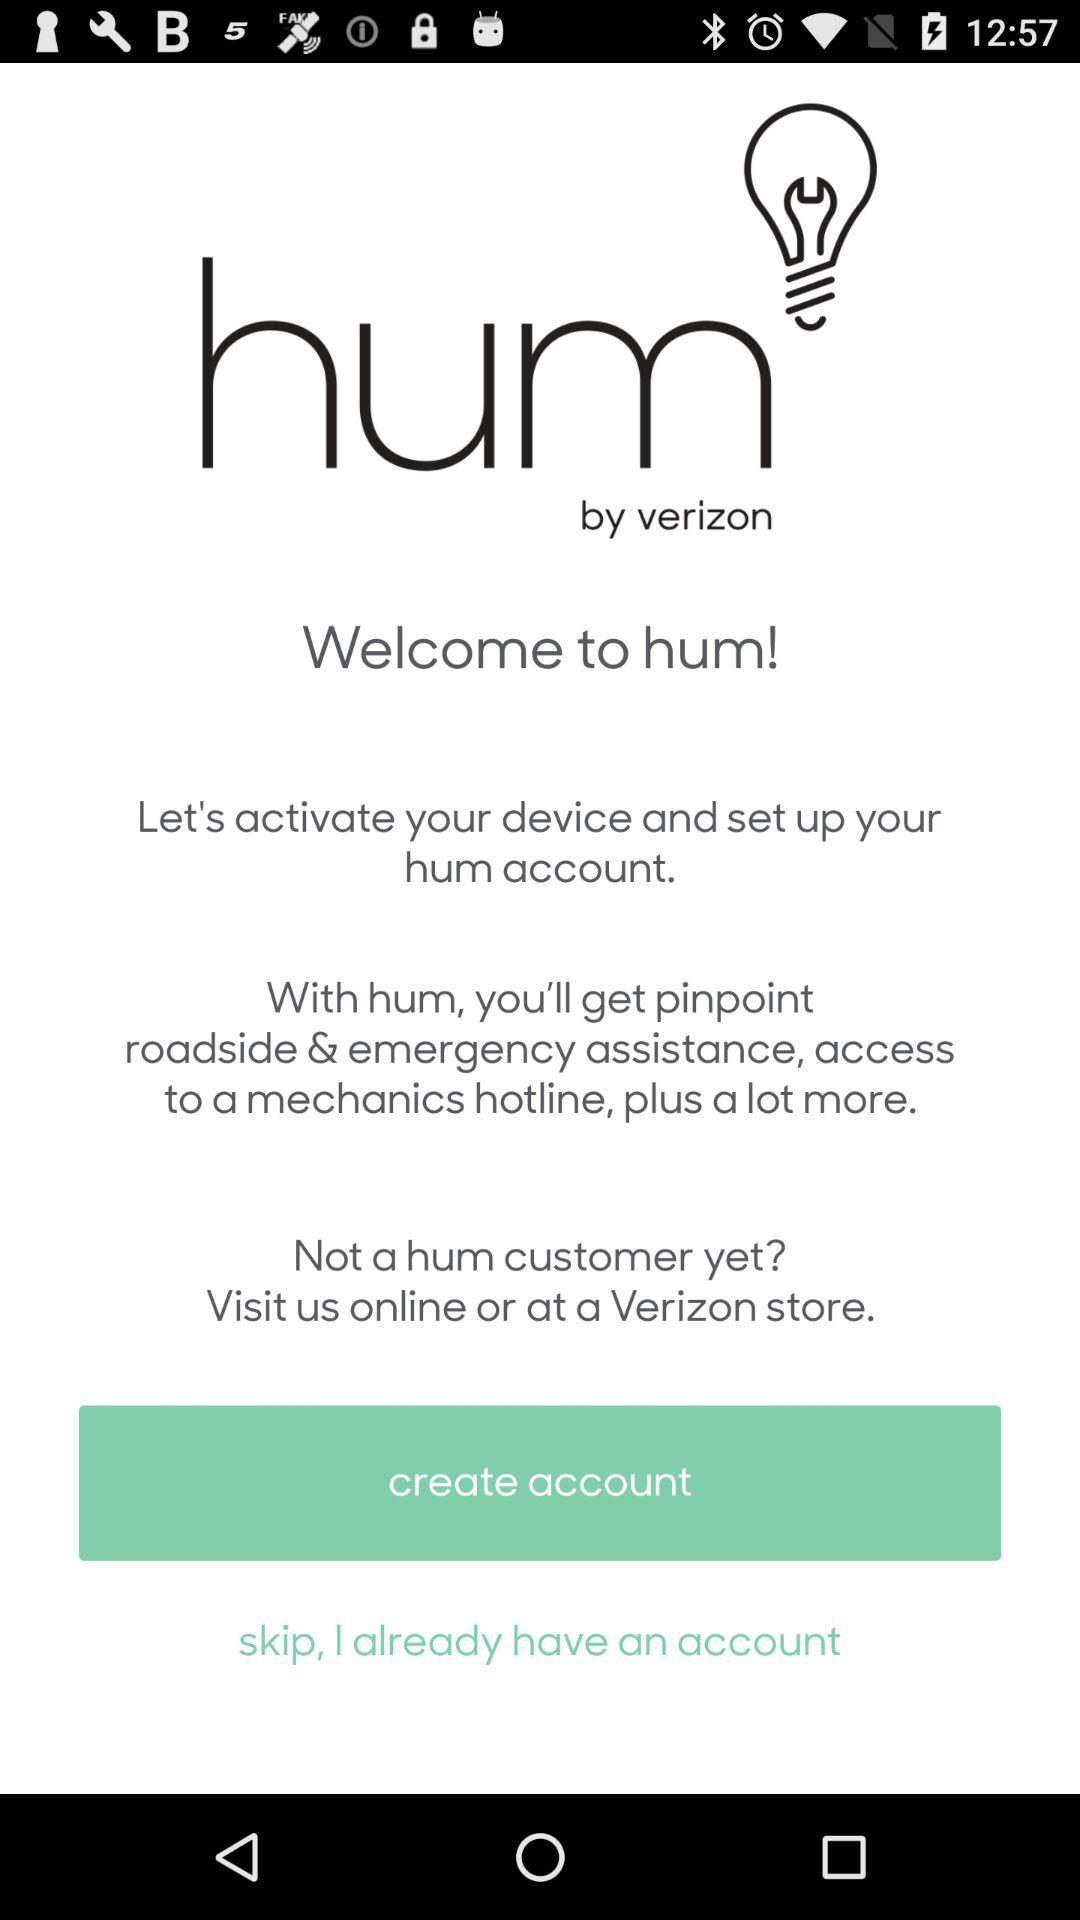Who owns the "hum" application? "hum" is owned by Verizon. 